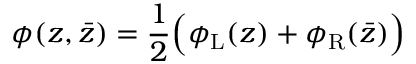Convert formula to latex. <formula><loc_0><loc_0><loc_500><loc_500>\phi ( z , \bar { z } ) = \frac { 1 } { 2 } \left ( \phi _ { L } ( z ) + \phi _ { R } ( \bar { z } ) \right )</formula> 